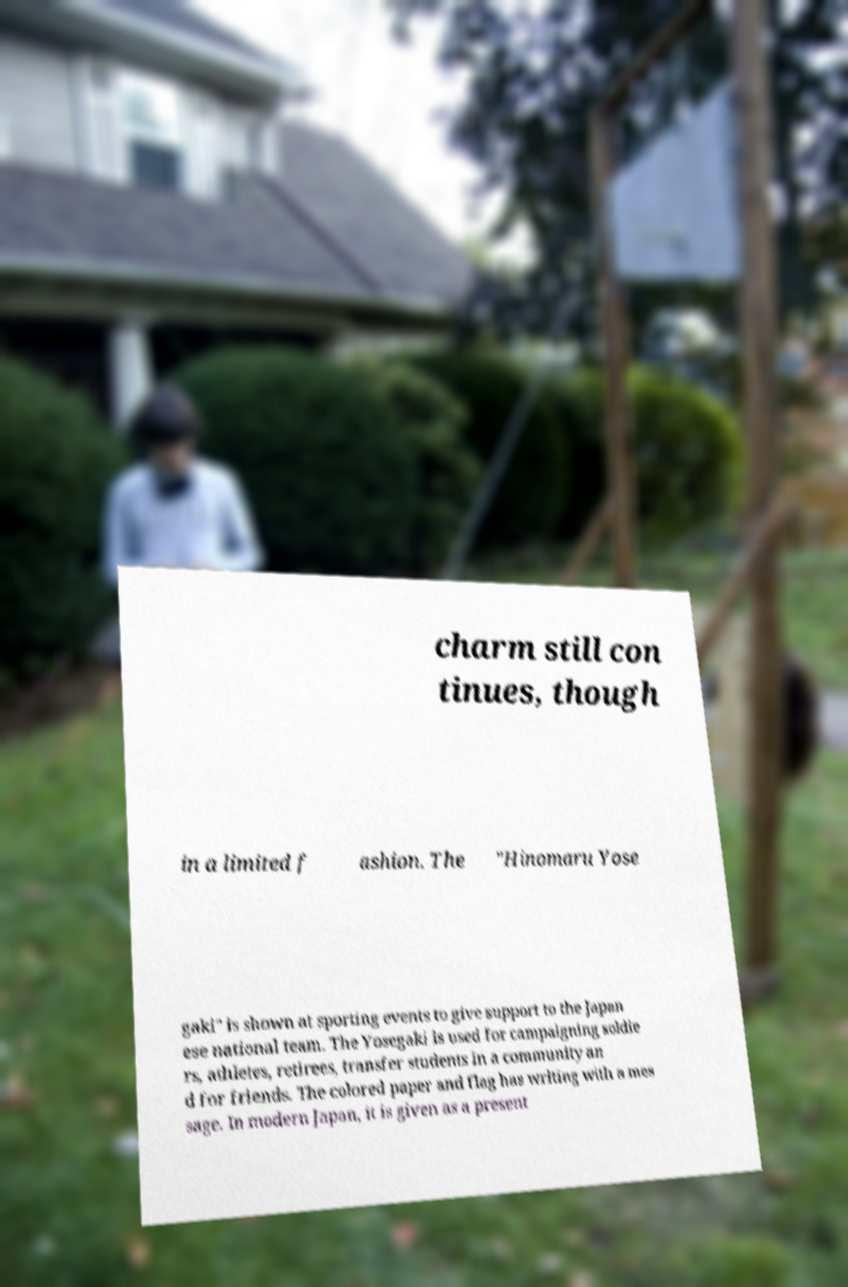Could you assist in decoding the text presented in this image and type it out clearly? charm still con tinues, though in a limited f ashion. The "Hinomaru Yose gaki" is shown at sporting events to give support to the Japan ese national team. The Yosegaki is used for campaigning soldie rs, athletes, retirees, transfer students in a community an d for friends. The colored paper and flag has writing with a mes sage. In modern Japan, it is given as a present 